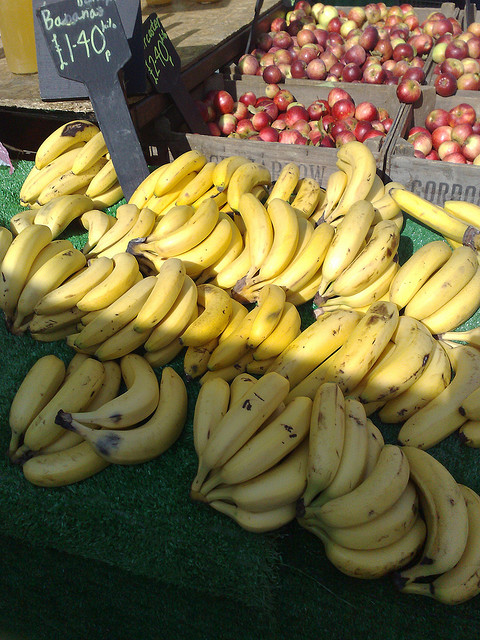Can you tell me about the setting of this fruit market? Sure, the image shows a vibrant outdoor fruit market scene. The bananas are placed in the forefront, with pricing clearly displayed on a small chalkboard sign. It gives an impression of a sunny day with fresh produce for sale. Are there any other details of note in the market? Beyond the bananas, there are bins of red and green fruits, which lend a colorful contrast to the scene and suggest a variety of fresh options for shoppers. The green artificial turf underneath the fruit displays adds a touch of greenery, and the handwritten signs imply a casual, local atmosphere. 